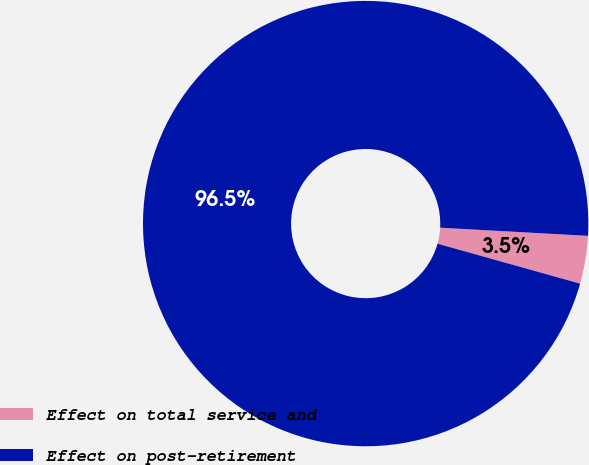<chart> <loc_0><loc_0><loc_500><loc_500><pie_chart><fcel>Effect on total service and<fcel>Effect on post-retirement<nl><fcel>3.47%<fcel>96.53%<nl></chart> 